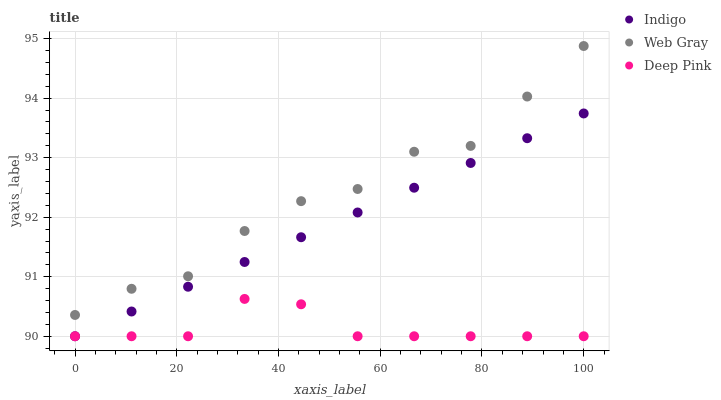Does Deep Pink have the minimum area under the curve?
Answer yes or no. Yes. Does Web Gray have the maximum area under the curve?
Answer yes or no. Yes. Does Indigo have the minimum area under the curve?
Answer yes or no. No. Does Indigo have the maximum area under the curve?
Answer yes or no. No. Is Indigo the smoothest?
Answer yes or no. Yes. Is Web Gray the roughest?
Answer yes or no. Yes. Is Deep Pink the smoothest?
Answer yes or no. No. Is Deep Pink the roughest?
Answer yes or no. No. Does Indigo have the lowest value?
Answer yes or no. Yes. Does Web Gray have the highest value?
Answer yes or no. Yes. Does Indigo have the highest value?
Answer yes or no. No. Is Deep Pink less than Web Gray?
Answer yes or no. Yes. Is Web Gray greater than Deep Pink?
Answer yes or no. Yes. Does Indigo intersect Deep Pink?
Answer yes or no. Yes. Is Indigo less than Deep Pink?
Answer yes or no. No. Is Indigo greater than Deep Pink?
Answer yes or no. No. Does Deep Pink intersect Web Gray?
Answer yes or no. No. 